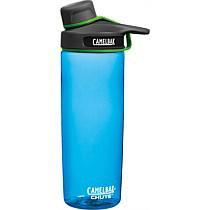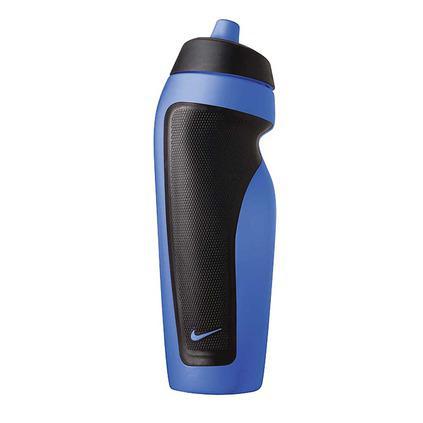The first image is the image on the left, the second image is the image on the right. For the images displayed, is the sentence "Both of the containers are made of a clear tinted material." factually correct? Answer yes or no. No. The first image is the image on the left, the second image is the image on the right. Examine the images to the left and right. Is the description "An image shows one water bottle with a black section and an indented shape." accurate? Answer yes or no. Yes. 